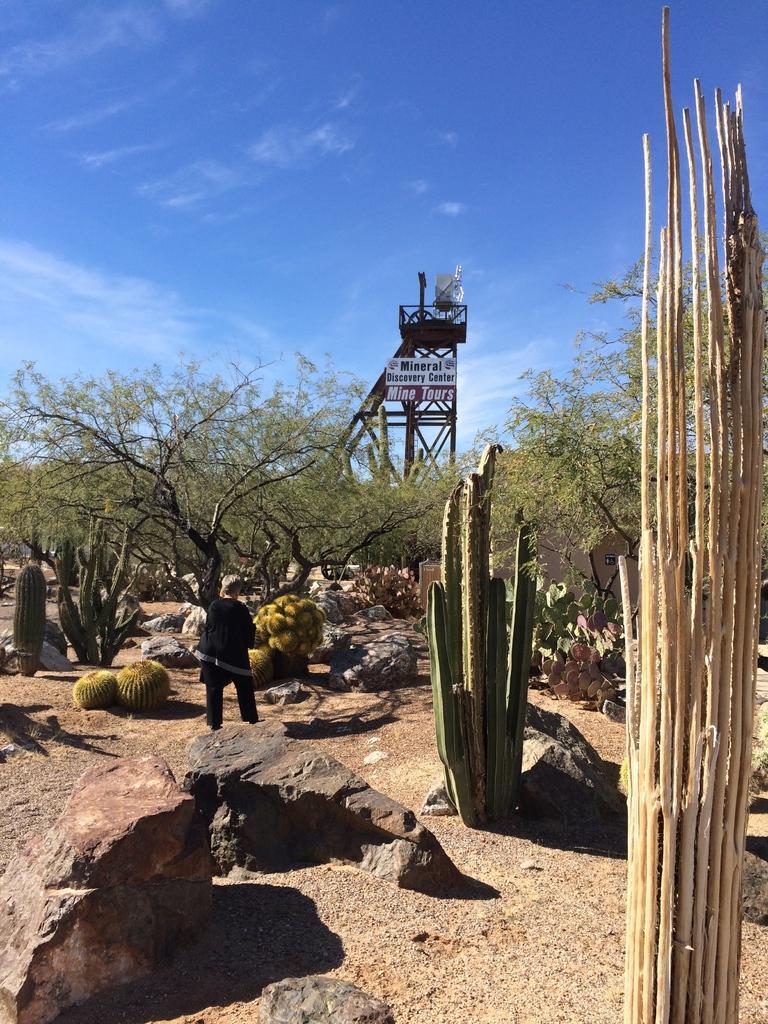Could you give a brief overview of what you see in this image? In this picture we can see a person standing on the ground. In front of the person, there are rocks, cactus plants, trees, a board and a tower. At the top of the image, there is the sky. 